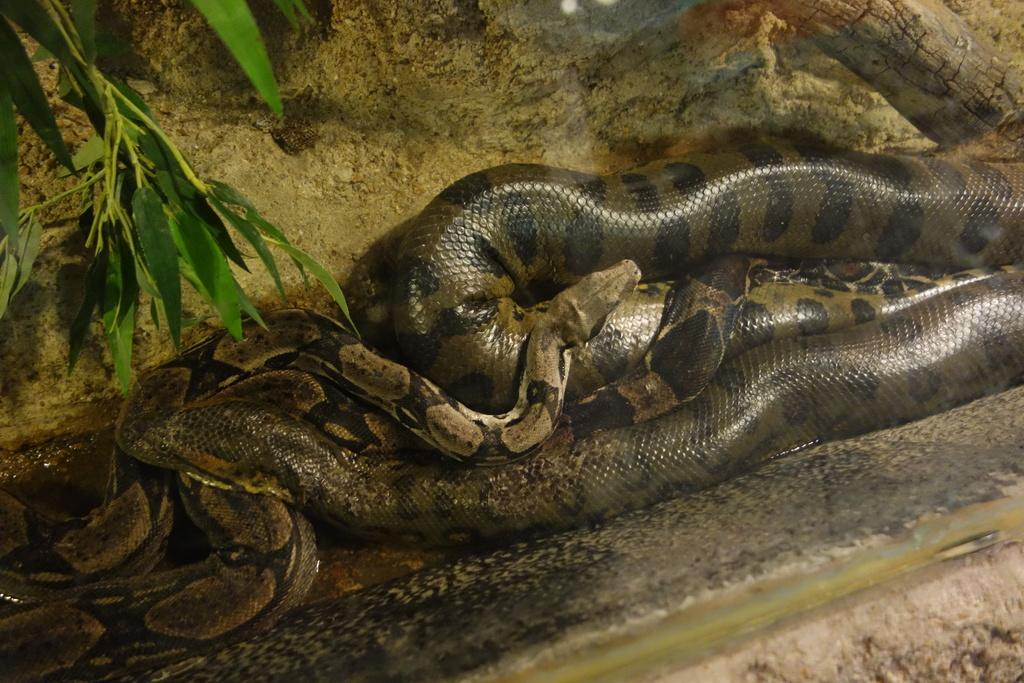What type of animals can be seen on the ground in the image? There are snakes on the ground in the image. What can be seen in the background of the image? There are leaves visible in the background of the image. What type of machine is being used by the snakes in the image? There is no machine present in the image; it features snakes on the ground and leaves in the background. 